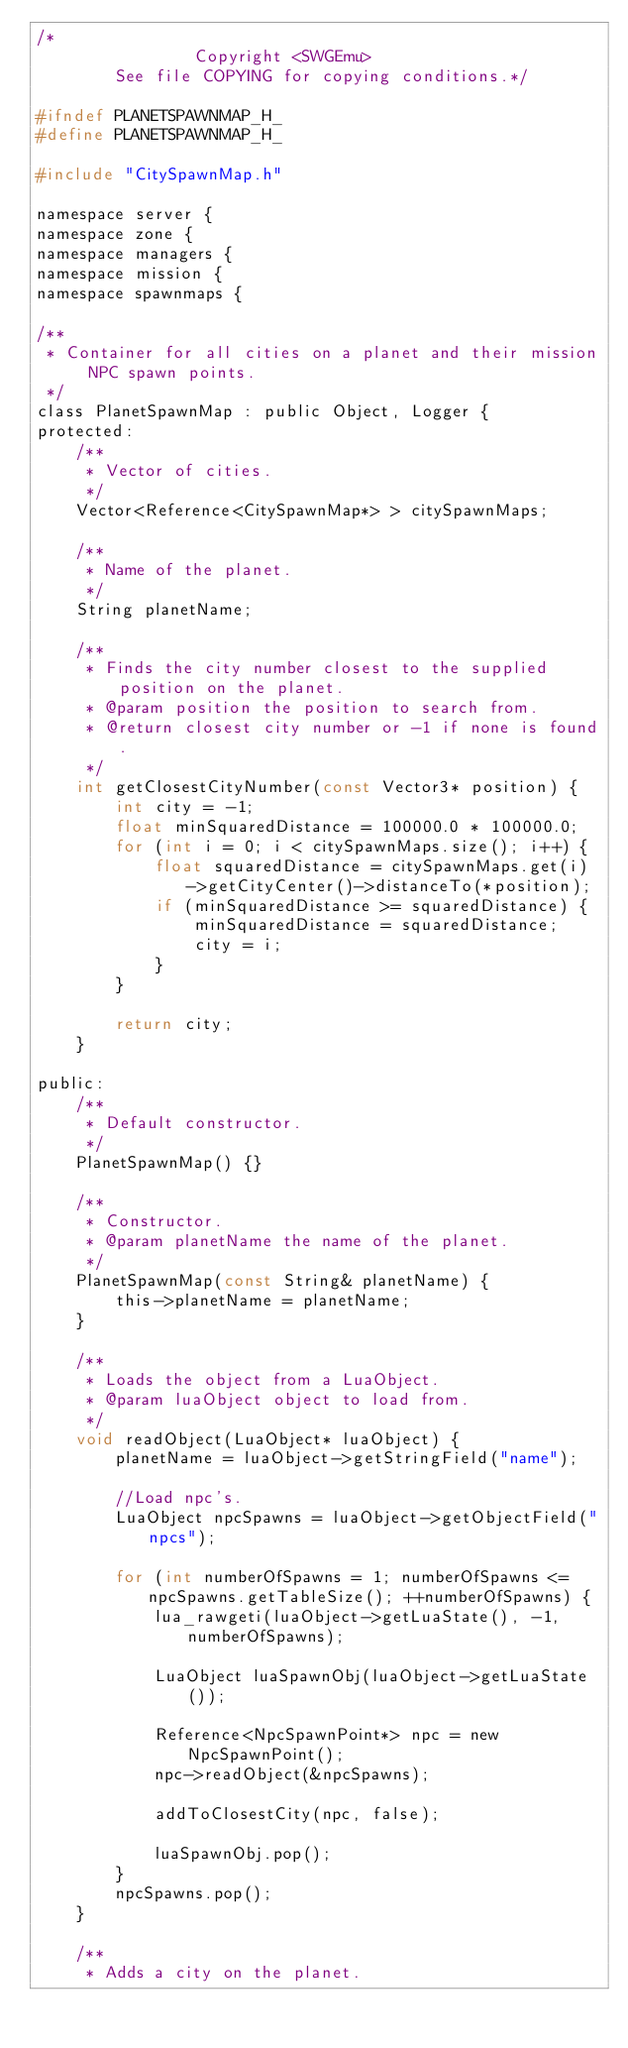Convert code to text. <code><loc_0><loc_0><loc_500><loc_500><_C_>/*
				Copyright <SWGEmu>
		See file COPYING for copying conditions.*/

#ifndef PLANETSPAWNMAP_H_
#define PLANETSPAWNMAP_H_

#include "CitySpawnMap.h"

namespace server {
namespace zone {
namespace managers {
namespace mission {
namespace spawnmaps {

/**
 * Container for all cities on a planet and their mission NPC spawn points.
 */
class PlanetSpawnMap : public Object, Logger {
protected:
	/**
	 * Vector of cities.
	 */
	Vector<Reference<CitySpawnMap*> > citySpawnMaps;

	/**
	 * Name of the planet.
	 */
	String planetName;

	/**
	 * Finds the city number closest to the supplied position on the planet.
	 * @param position the position to search from.
	 * @return closest city number or -1 if none is found.
	 */
	int getClosestCityNumber(const Vector3* position) {
		int city = -1;
		float minSquaredDistance = 100000.0 * 100000.0;
		for (int i = 0; i < citySpawnMaps.size(); i++) {
			float squaredDistance = citySpawnMaps.get(i)->getCityCenter()->distanceTo(*position);
			if (minSquaredDistance >= squaredDistance) {
				minSquaredDistance = squaredDistance;
				city = i;
			}
		}

		return city;
	}

public:
	/**
	 * Default constructor.
	 */
	PlanetSpawnMap() {}

	/**
	 * Constructor.
	 * @param planetName the name of the planet.
	 */
	PlanetSpawnMap(const String& planetName) {
		this->planetName = planetName;
	}

	/**
	 * Loads the object from a LuaObject.
	 * @param luaObject object to load from.
	 */
	void readObject(LuaObject* luaObject) {
		planetName = luaObject->getStringField("name");

		//Load npc's.
		LuaObject npcSpawns = luaObject->getObjectField("npcs");

		for (int numberOfSpawns = 1; numberOfSpawns <= npcSpawns.getTableSize(); ++numberOfSpawns) {
			lua_rawgeti(luaObject->getLuaState(), -1, numberOfSpawns);

			LuaObject luaSpawnObj(luaObject->getLuaState());

			Reference<NpcSpawnPoint*> npc = new NpcSpawnPoint();
			npc->readObject(&npcSpawns);

			addToClosestCity(npc, false);

			luaSpawnObj.pop();
		}
		npcSpawns.pop();
	}

	/**
	 * Adds a city on the planet.</code> 